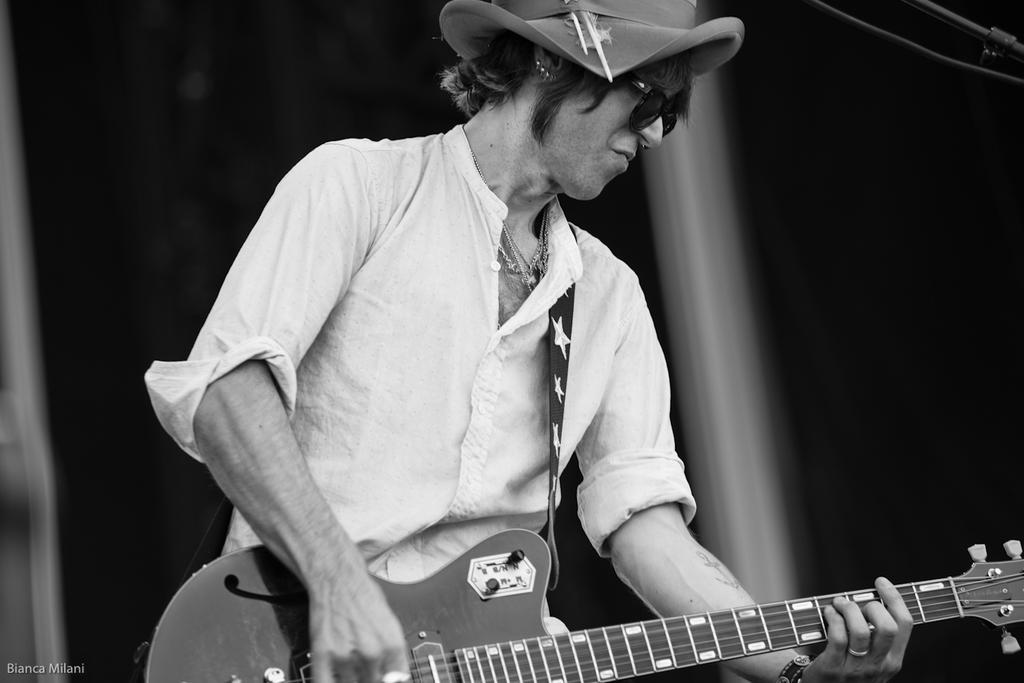In one or two sentences, can you explain what this image depicts? This Image is clicked in a musical concert. It is a black and white image. Person is holding guitar, he is wearing specs and hat. He is in the middle of the image. 